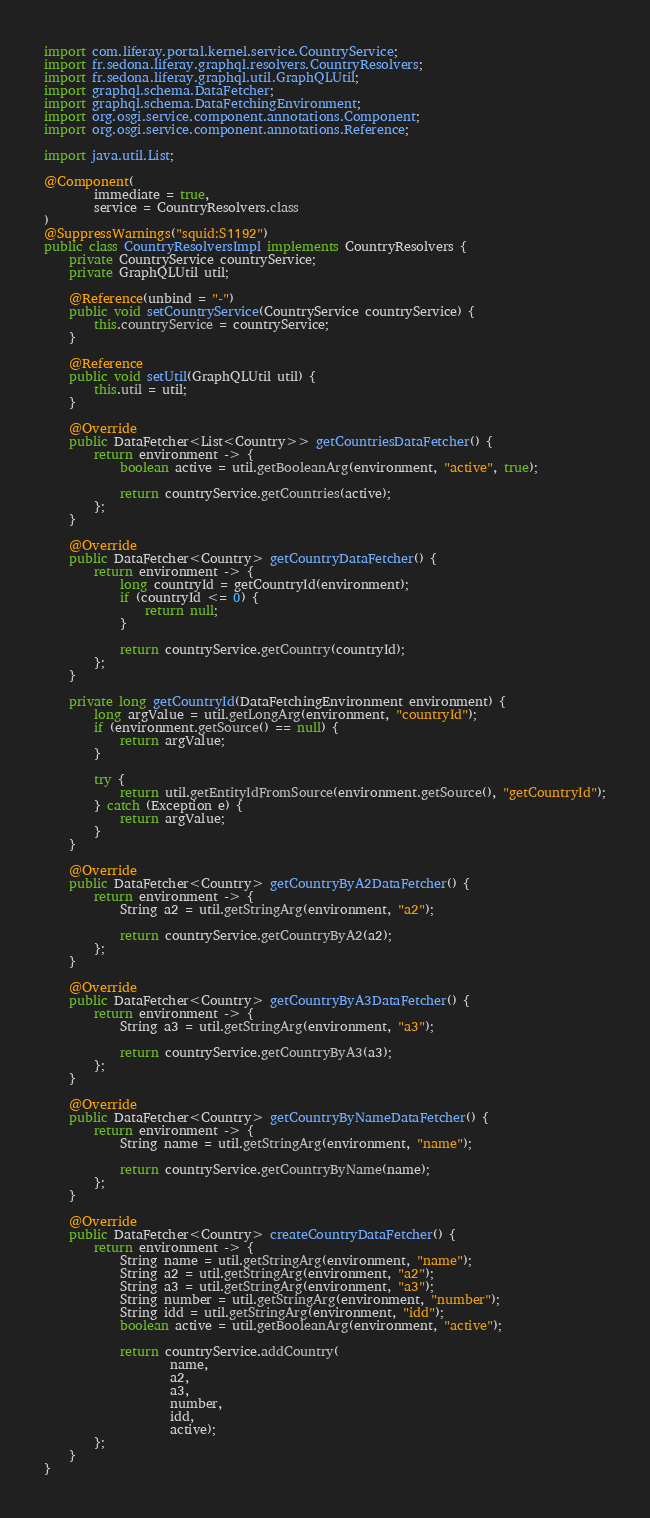<code> <loc_0><loc_0><loc_500><loc_500><_Java_>import com.liferay.portal.kernel.service.CountryService;
import fr.sedona.liferay.graphql.resolvers.CountryResolvers;
import fr.sedona.liferay.graphql.util.GraphQLUtil;
import graphql.schema.DataFetcher;
import graphql.schema.DataFetchingEnvironment;
import org.osgi.service.component.annotations.Component;
import org.osgi.service.component.annotations.Reference;

import java.util.List;

@Component(
        immediate = true,
        service = CountryResolvers.class
)
@SuppressWarnings("squid:S1192")
public class CountryResolversImpl implements CountryResolvers {
    private CountryService countryService;
    private GraphQLUtil util;

    @Reference(unbind = "-")
    public void setCountryService(CountryService countryService) {
        this.countryService = countryService;
    }

    @Reference
    public void setUtil(GraphQLUtil util) {
        this.util = util;
    }

    @Override
    public DataFetcher<List<Country>> getCountriesDataFetcher() {
        return environment -> {
            boolean active = util.getBooleanArg(environment, "active", true);

            return countryService.getCountries(active);
        };
    }

    @Override
    public DataFetcher<Country> getCountryDataFetcher() {
        return environment -> {
            long countryId = getCountryId(environment);
            if (countryId <= 0) {
                return null;
            }

            return countryService.getCountry(countryId);
        };
    }

    private long getCountryId(DataFetchingEnvironment environment) {
        long argValue = util.getLongArg(environment, "countryId");
        if (environment.getSource() == null) {
            return argValue;
        }

        try {
            return util.getEntityIdFromSource(environment.getSource(), "getCountryId");
        } catch (Exception e) {
            return argValue;
        }
    }

    @Override
    public DataFetcher<Country> getCountryByA2DataFetcher() {
        return environment -> {
            String a2 = util.getStringArg(environment, "a2");

            return countryService.getCountryByA2(a2);
        };
    }

    @Override
    public DataFetcher<Country> getCountryByA3DataFetcher() {
        return environment -> {
            String a3 = util.getStringArg(environment, "a3");

            return countryService.getCountryByA3(a3);
        };
    }

    @Override
    public DataFetcher<Country> getCountryByNameDataFetcher() {
        return environment -> {
            String name = util.getStringArg(environment, "name");

            return countryService.getCountryByName(name);
        };
    }

    @Override
    public DataFetcher<Country> createCountryDataFetcher() {
        return environment -> {
            String name = util.getStringArg(environment, "name");
            String a2 = util.getStringArg(environment, "a2");
            String a3 = util.getStringArg(environment, "a3");
            String number = util.getStringArg(environment, "number");
            String idd = util.getStringArg(environment, "idd");
            boolean active = util.getBooleanArg(environment, "active");

            return countryService.addCountry(
                    name,
                    a2,
                    a3,
                    number,
                    idd,
                    active);
        };
    }
}
</code> 